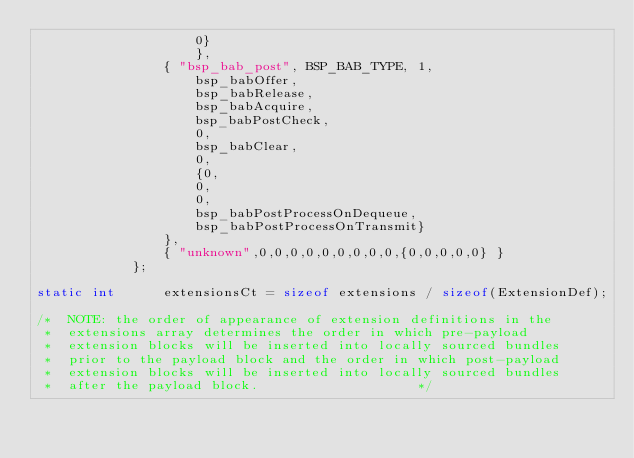<code> <loc_0><loc_0><loc_500><loc_500><_C_>					0}
			       	},
				{ "bsp_bab_post", BSP_BAB_TYPE, 1,
					bsp_babOffer,
					bsp_babRelease,
					bsp_babAcquire,
					bsp_babPostCheck,
					0,
					bsp_babClear,
					0,
					{0,
					0,
					0,
					bsp_babPostProcessOnDequeue,
					bsp_babPostProcessOnTransmit}
				},
				{ "unknown",0,0,0,0,0,0,0,0,0,{0,0,0,0,0} }
			};

static int		extensionsCt = sizeof extensions / sizeof(ExtensionDef);

/*	NOTE: the order of appearance of extension definitions in the
 *	extensions array determines the order in which pre-payload
 *	extension blocks will be inserted into locally sourced bundles
 *	prior to the payload block and the order in which post-payload
 *	extension blocks will be inserted into locally sourced bundles
 *	after the payload block.					*/
</code> 